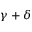<formula> <loc_0><loc_0><loc_500><loc_500>\gamma + \delta</formula> 